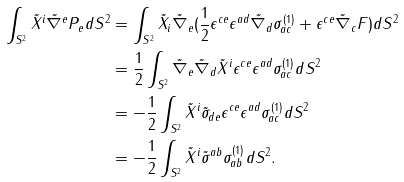Convert formula to latex. <formula><loc_0><loc_0><loc_500><loc_500>\int _ { S ^ { 2 } } \tilde { X } ^ { i } \tilde { \nabla } ^ { e } P _ { e } d S ^ { 2 } & = \int _ { S ^ { 2 } } \tilde { X } _ { i } \tilde { \nabla } _ { e } ( \frac { 1 } { 2 } \epsilon ^ { c e } \epsilon ^ { a d } \tilde { \nabla } _ { d } \sigma ^ { ( 1 ) } _ { a c } + \epsilon ^ { c e } \tilde { \nabla } _ { c } F ) d S ^ { 2 } \\ & = \frac { 1 } { 2 } \int _ { S ^ { 2 } } \tilde { \nabla } _ { e } \tilde { \nabla } _ { d } \tilde { X } ^ { i } \epsilon ^ { c e } \epsilon ^ { a d } \sigma ^ { ( 1 ) } _ { a c } d S ^ { 2 } \\ & = - \frac { 1 } { 2 } \int _ { S ^ { 2 } } \tilde { X } ^ { i } \tilde { \sigma } _ { d e } \epsilon ^ { c e } \epsilon ^ { a d } \sigma ^ { ( 1 ) } _ { a c } d S ^ { 2 } \\ & = - \frac { 1 } { 2 } \int _ { S ^ { 2 } } \tilde { X } ^ { i } \tilde { \sigma } ^ { a b } \sigma ^ { ( 1 ) } _ { a b } d S ^ { 2 } .</formula> 